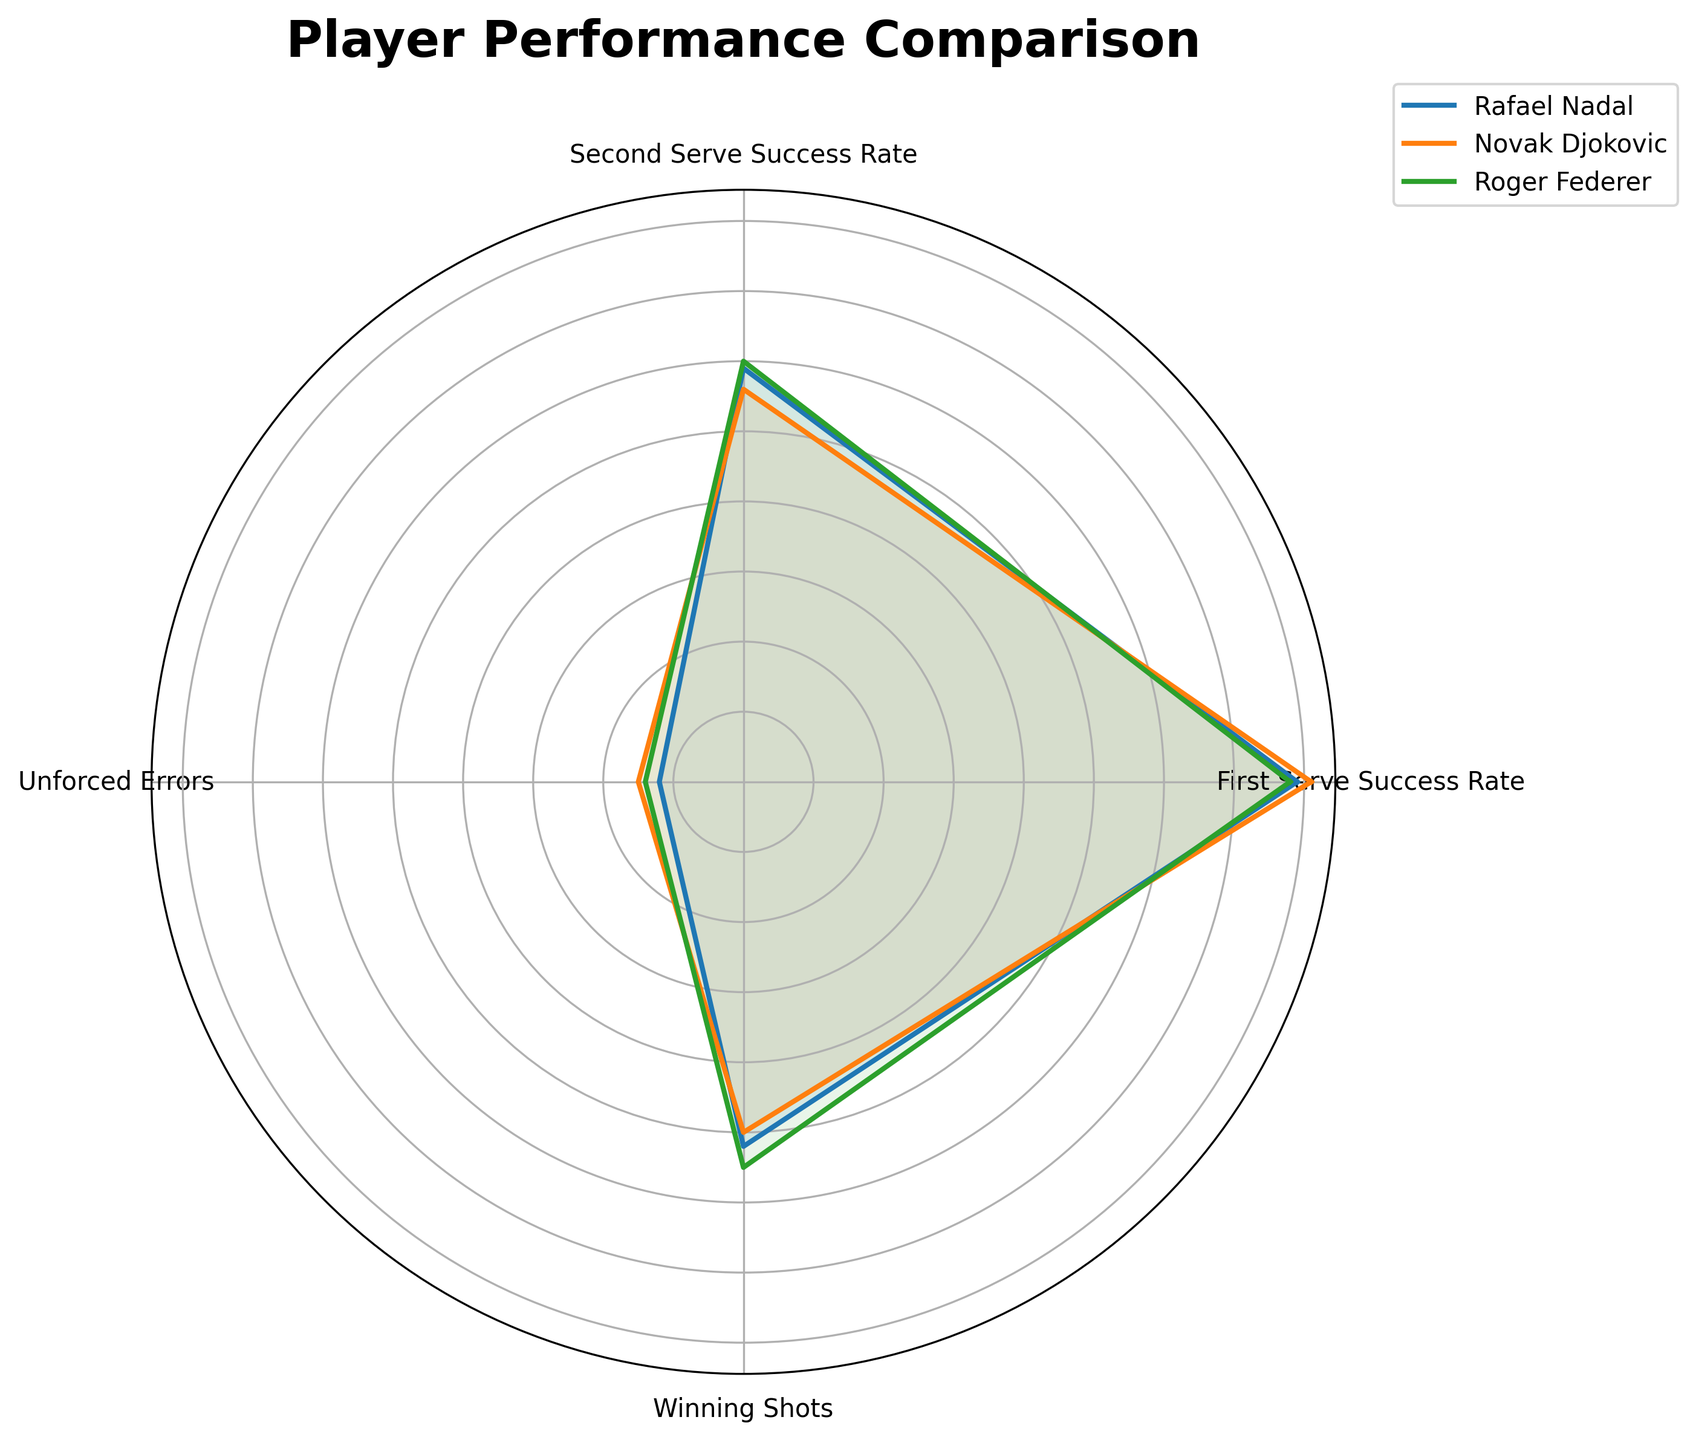How many players' performance data are compared? The figure displays radar charts with three different colored lines, each representing the performance data for Rafael Nadal, Novak Djokovic, and Roger Federer.
Answer: 3 What is the title of the figure? The title of the figure, placed at the top, states "Player Performance Comparison."
Answer: Player Performance Comparison Which player has the highest Second Serve Success Rate? Looking at the radial axis under "Second Serve Success Rate," the line representing Roger Federer extends the farthest, indicating the highest value.
Answer: Roger Federer Compare the Winning Shots of Rafael Nadal and Novak Djokovic. Who has more? Looking at the radar chart segment labeled "Winning Shots," the line for Novak Djokovic extends further than Rafael Nadal's, indicating that Djokovic has more Winning Shots.
Answer: Novak Djokovic What is the range of First Serve Success Rates among the three players? Refer to the "First Serve Success Rate" segment. Federer's line extends to 78, Djokovic's to 79, and Nadal's to 81. The range is the difference between the highest and lowest values: 81 - 78.
Answer: 3 Which player has the fewest Unforced Errors? By examining the "Unforced Errors" segment of the radar chart, Novak Djokovic's line is the shortest, indicating the fewest Unforced Errors.
Answer: Novak Djokovic Between Rafael Nadal and Daniil Medvedev, who has a higher average success rate for both serves combined (First and Second Serve Success Rate)? Calculate Nadal’s and Medvedev's combined success rates: Nadal (81 + 56) = 137, Medvedev (76 + 57) = 133. Nadal has a higher combined success rate.
Answer: Rafael Nadal How does Roger Federer’s performance in Unforced Errors compare to Daniil Medvedev’s? The radar chart for "Unforced Errors" shows Federer's value at 14 and Medvedev's at 13. Both are close, with Medvedev having slightly fewer unforced errors.
Answer: Daniil Medvedev Which player shows the most balanced performance across all metrics? Observe the radar chart’s shapes: Rafael Nadal's and Novak Djokovic's radar areas appear more balanced and less irregular compared to Roger Federer's. Among these, Nadal exhibits slightly more balance.
Answer: Rafael Nadal 